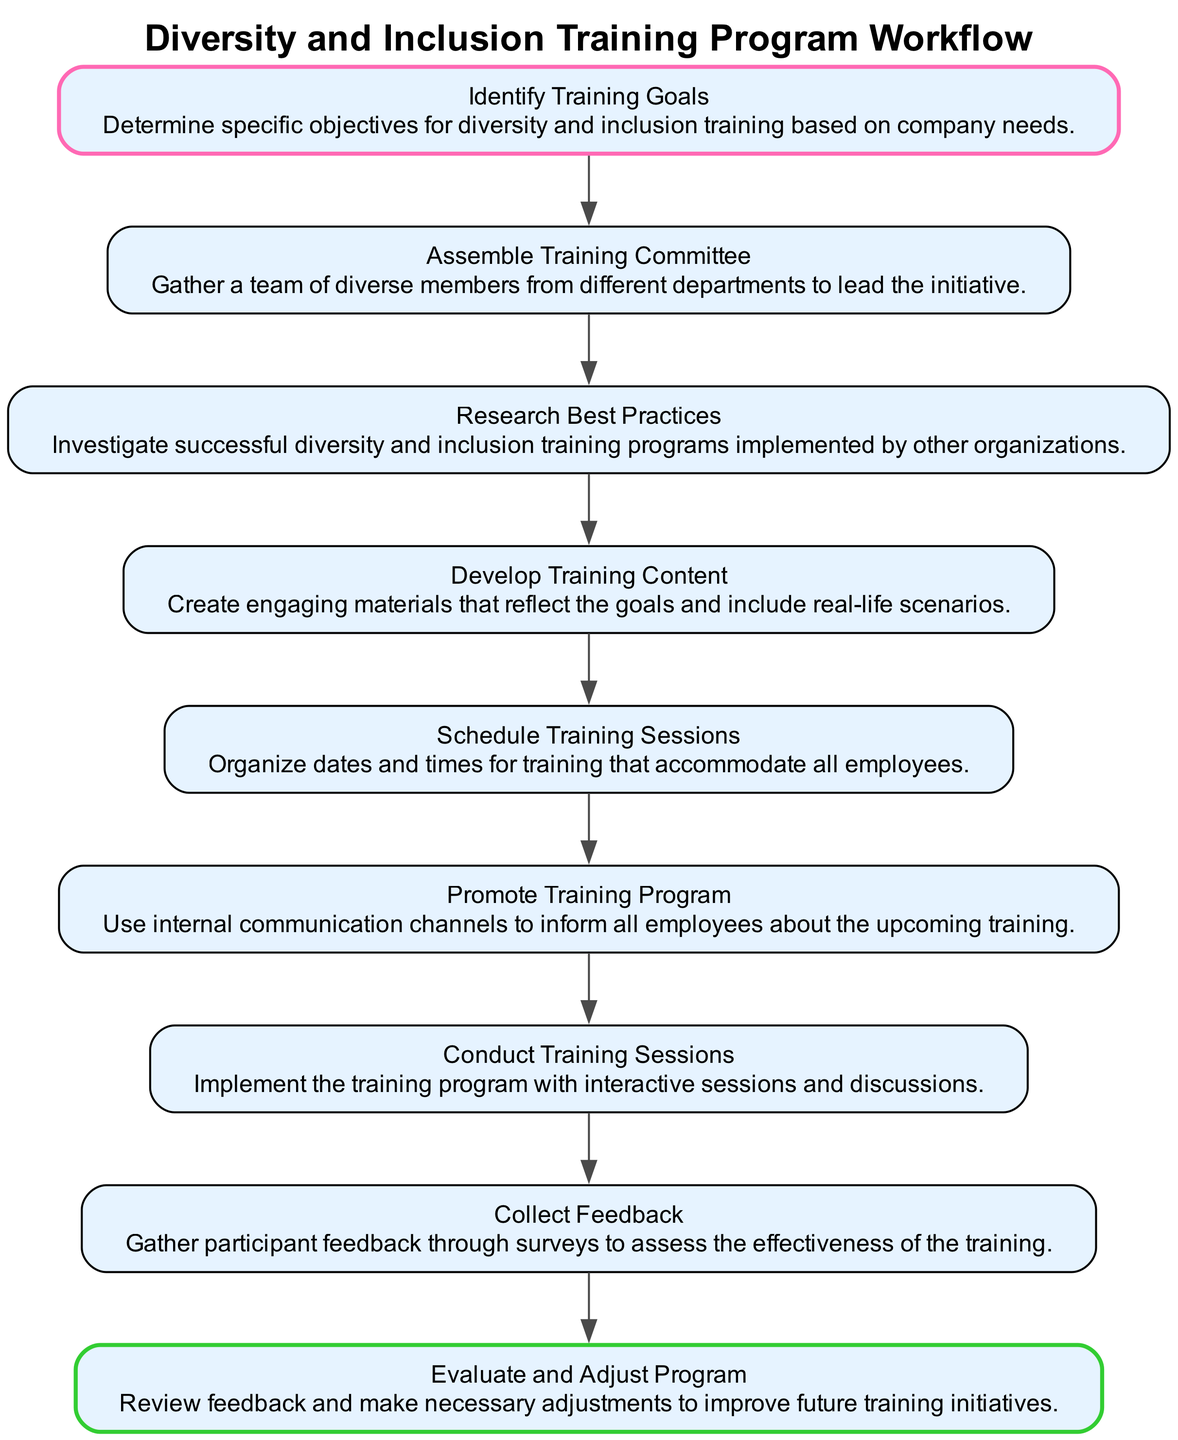What is the first step in the workflow? The first step is labeled "Identify Training Goals," which is indicated as the starting node in the flow chart.
Answer: Identify Training Goals How many nodes are in the diagram? By counting the distinct elements listed, there are a total of nine nodes present in the diagram.
Answer: 9 What does the "Evaluate and Adjust Program" step involve? The description provided for this node states that it involves reviewing feedback and making necessary adjustments for future training initiatives, which is indicated below the corresponding node.
Answer: Review feedback and make necessary adjustments Which step comes immediately after "Conduct Training Sessions"? The flow proceeds to "Collect Feedback" directly following "Conduct Training Sessions," as depicted by the connecting edge between these two nodes.
Answer: Collect Feedback What color highlights the beginning and end steps of the workflow? The first step is highlighted in pink, and the last step is highlighted in green, which can be seen through the colors assigned to the respective nodes in the diagram.
Answer: Pink and Green What is the purpose of the "Assemble Training Committee" step? This step aims to gather a team of diverse members from different departments to lead the initiative, as described in the node information.
Answer: Gather a team of diverse members How does the "Research Best Practices" relate to "Develop Training Content"? "Research Best Practices" feeds into "Develop Training Content," as the insights gained from researching informs the content creation, evident by the sequential flow from one node to the next.
Answer: Informs content creation What is the final action taken in this workflow? The final action to be carried out in the workflow is "Evaluate and Adjust Program," marking the completion of this training program process.
Answer: Evaluate and Adjust Program 